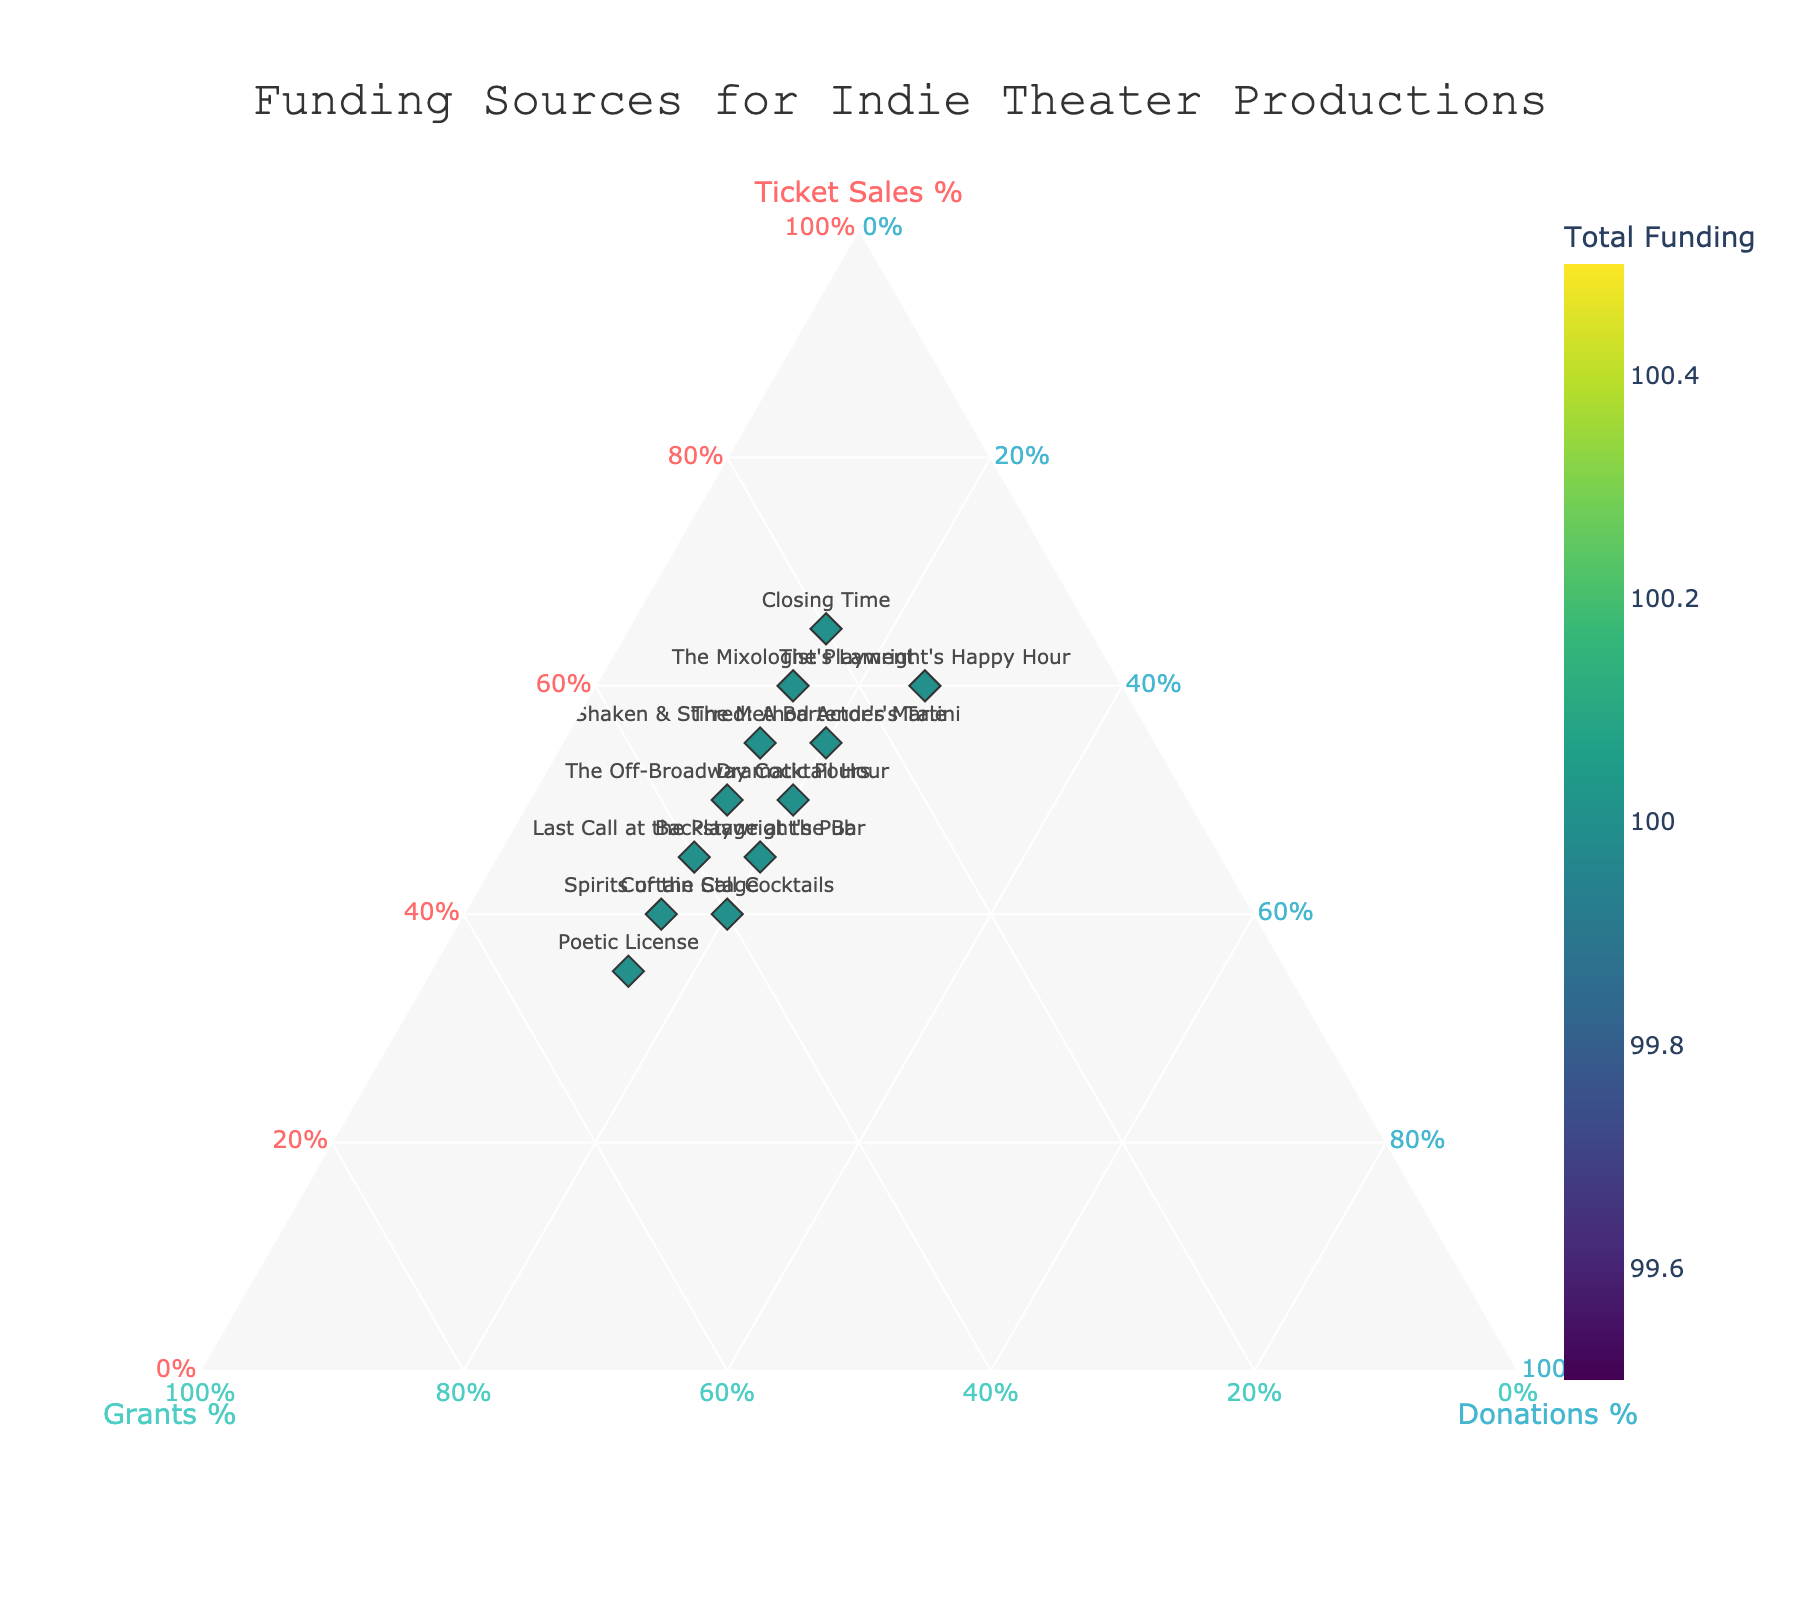how many productions are represented in the plot? Count the number of unique productions listed in the figure.
Answer: 12 What is the title of the plot? Look at the title text displayed at the top of the figure.
Answer: Funding Sources for Indie Theater Productions Which production has the highest percentage of ticket sales? Locate the point that corresponds to the highest value on the 'Ticket Sales %' axis.
Answer: Closing Time Which production receives the highest percentage from grants? Locate the point that corresponds to the highest value on the 'Grants %' axis.
Answer: Poetic License How many productions have equal contributions of 15% from donations? Count the number of points where the 'Donations %' value is 15%.
Answer: 7 What percentage of funding does "The Mixologist's Lament" receive from ticket sales? Look at the point labeled "The Mixologist's Lament" and note its 'Ticket Sales %' value.
Answer: 60% Which production has the smallest total funding? Look at the color bar indicating total funding and find the point with the lightest color.
Answer: Poetic License Compare the total funding amounts for "Last Call at the Playwright's Pub" and "Closing Time". Which one is higher? Find the points for both productions and compare their positions on the color bar scale.
Answer: Closing Time What is the common percentage contributed by donations across most productions? Observe the donations axis where most points are aligned and note the common value.
Answer: 15% Among the productions, which one has a balanced distribution between Ticket Sales, Grants, and Donations? Look for a point approximately centered within the ternary plot, indicating balanced funding.
Answer: The Method Actor's Martini 